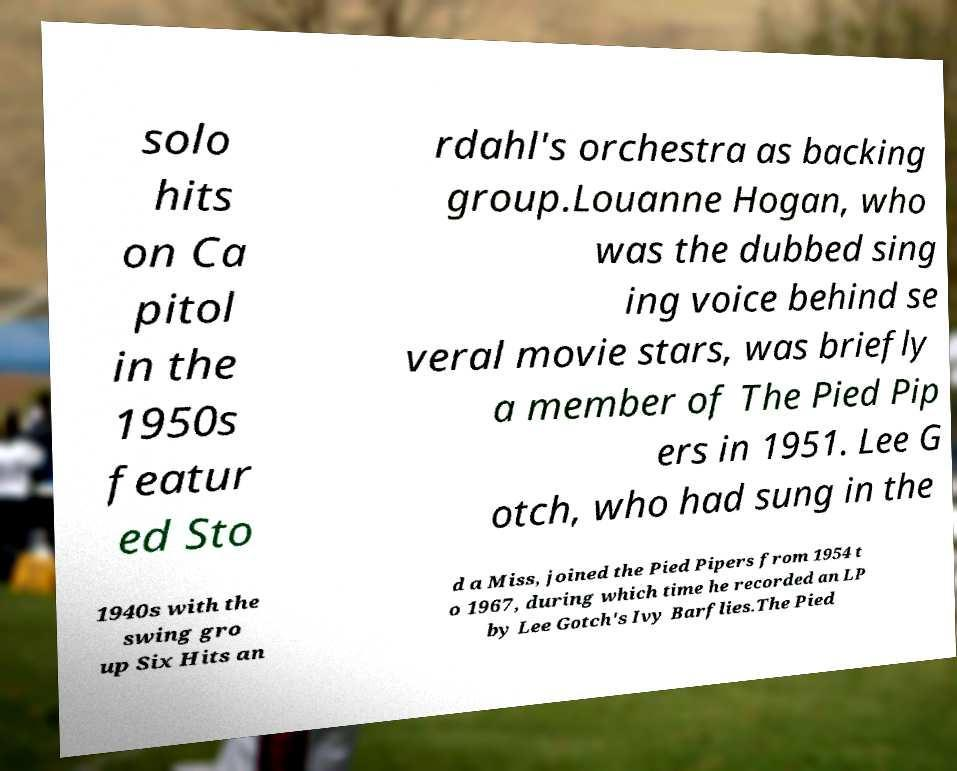There's text embedded in this image that I need extracted. Can you transcribe it verbatim? solo hits on Ca pitol in the 1950s featur ed Sto rdahl's orchestra as backing group.Louanne Hogan, who was the dubbed sing ing voice behind se veral movie stars, was briefly a member of The Pied Pip ers in 1951. Lee G otch, who had sung in the 1940s with the swing gro up Six Hits an d a Miss, joined the Pied Pipers from 1954 t o 1967, during which time he recorded an LP by Lee Gotch's Ivy Barflies.The Pied 